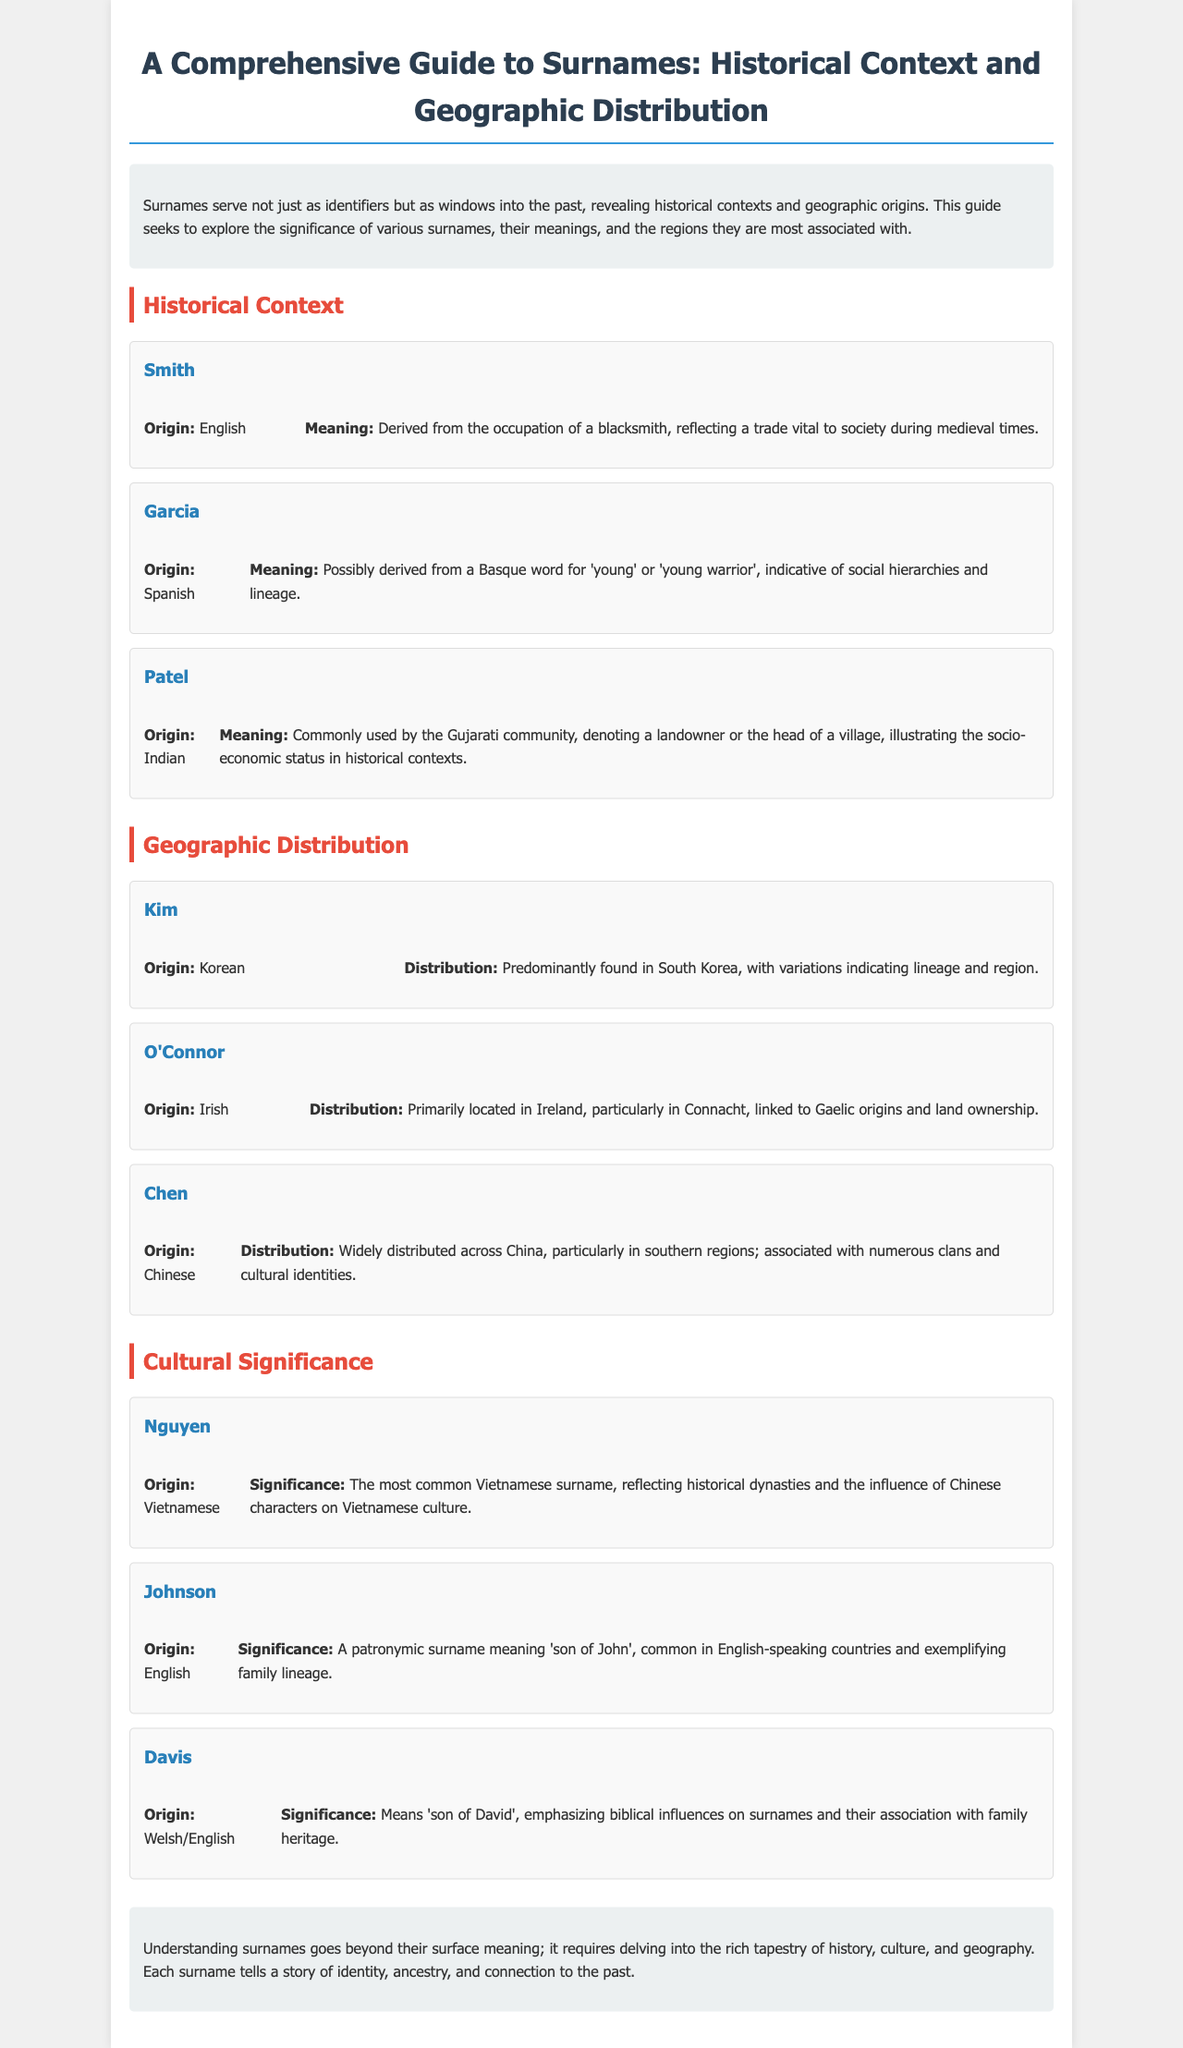What is the origin of the surname "Smith"? The document states that "Smith" has an English origin.
Answer: English What does the surname "Garcia" possibly mean? The meaning of "Garcia" is derived from a Basque word for 'young' or 'young warrior'.
Answer: young or young warrior Which surname is primarily found in South Korea? The document mentions "Kim" as predominantly found in South Korea.
Answer: Kim What is the cultural significance of the surname "Nguyen"? "Nguyen" is the most common Vietnamese surname reflecting historical dynasties.
Answer: historical dynasties What is the meaning of the surname "Davis"? The surname "Davis" means 'son of David'.
Answer: son of David How many surnames are discussed under the Historical Context section? There are three surnames listed in that section.
Answer: three Which surname indicates a landowner in historical contexts? The surname "Patel" denotes a landowner or the head of a village.
Answer: Patel What region is associated with the surname "O'Connor"? The document states that "O'Connor" is primarily located in Ireland, particularly in Connacht.
Answer: Ireland 